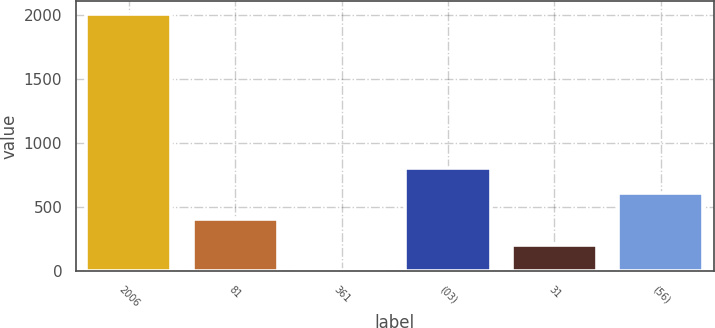Convert chart. <chart><loc_0><loc_0><loc_500><loc_500><bar_chart><fcel>2006<fcel>81<fcel>361<fcel>(03)<fcel>31<fcel>(56)<nl><fcel>2004<fcel>405.12<fcel>5.4<fcel>804.84<fcel>205.26<fcel>604.98<nl></chart> 